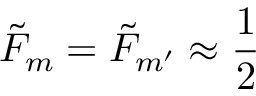<formula> <loc_0><loc_0><loc_500><loc_500>{ \tilde { F } } _ { m } = { \tilde { F } } _ { m { ^ { \prime } } } \approx \frac { 1 } { 2 }</formula> 